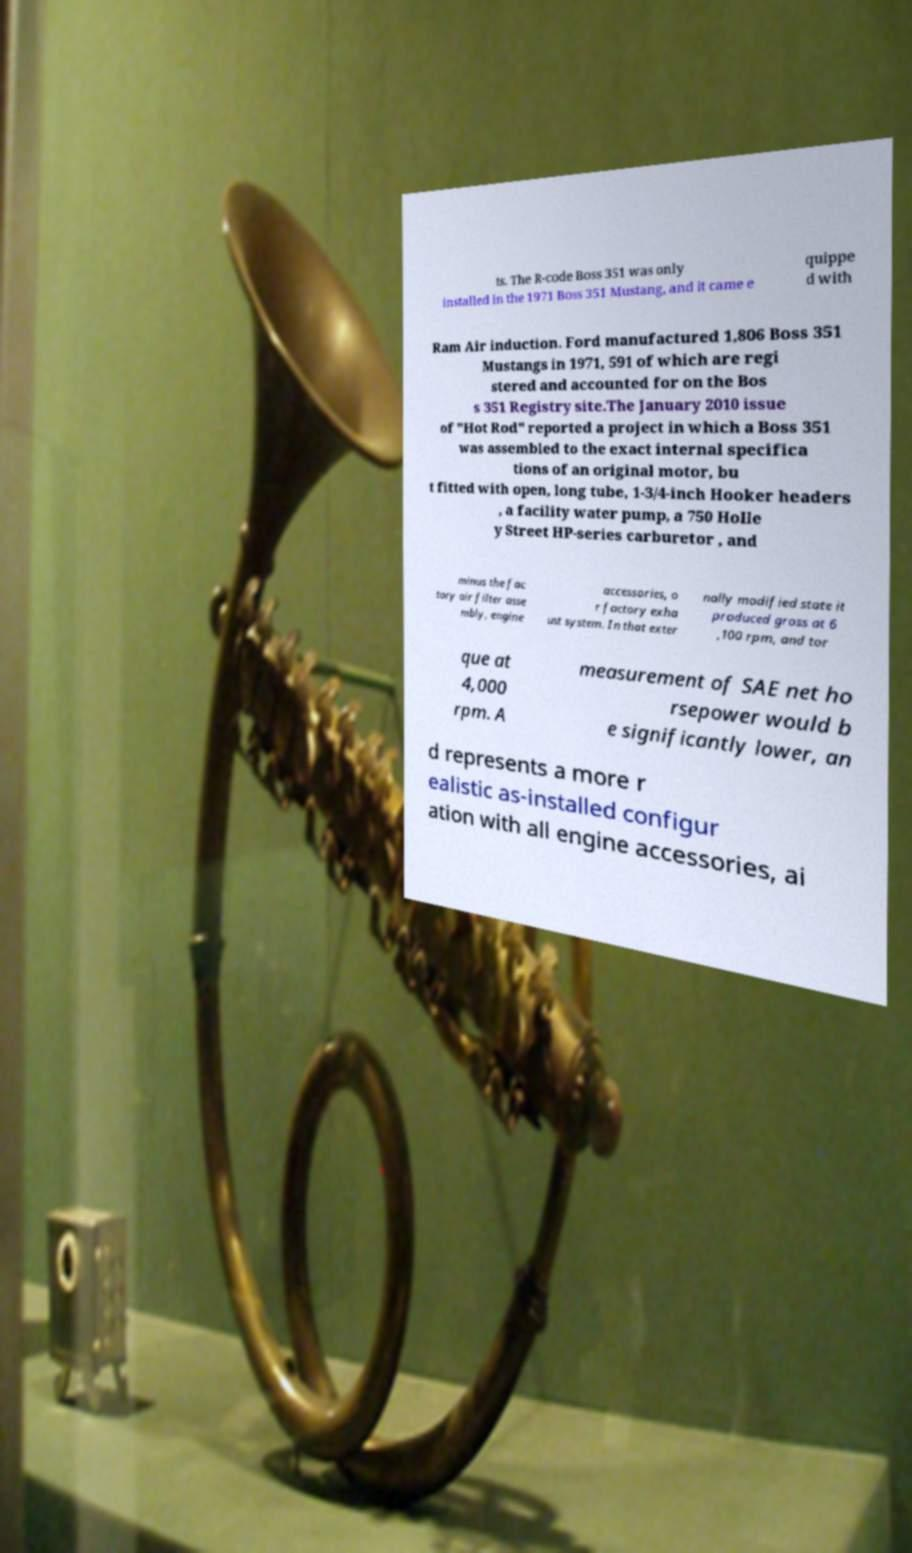What messages or text are displayed in this image? I need them in a readable, typed format. ts. The R-code Boss 351 was only installed in the 1971 Boss 351 Mustang, and it came e quippe d with Ram Air induction. Ford manufactured 1,806 Boss 351 Mustangs in 1971, 591 of which are regi stered and accounted for on the Bos s 351 Registry site.The January 2010 issue of "Hot Rod" reported a project in which a Boss 351 was assembled to the exact internal specifica tions of an original motor, bu t fitted with open, long tube, 1-3/4-inch Hooker headers , a facility water pump, a 750 Holle y Street HP-series carburetor , and minus the fac tory air filter asse mbly, engine accessories, o r factory exha ust system. In that exter nally modified state it produced gross at 6 ,100 rpm, and tor que at 4,000 rpm. A measurement of SAE net ho rsepower would b e significantly lower, an d represents a more r ealistic as-installed configur ation with all engine accessories, ai 